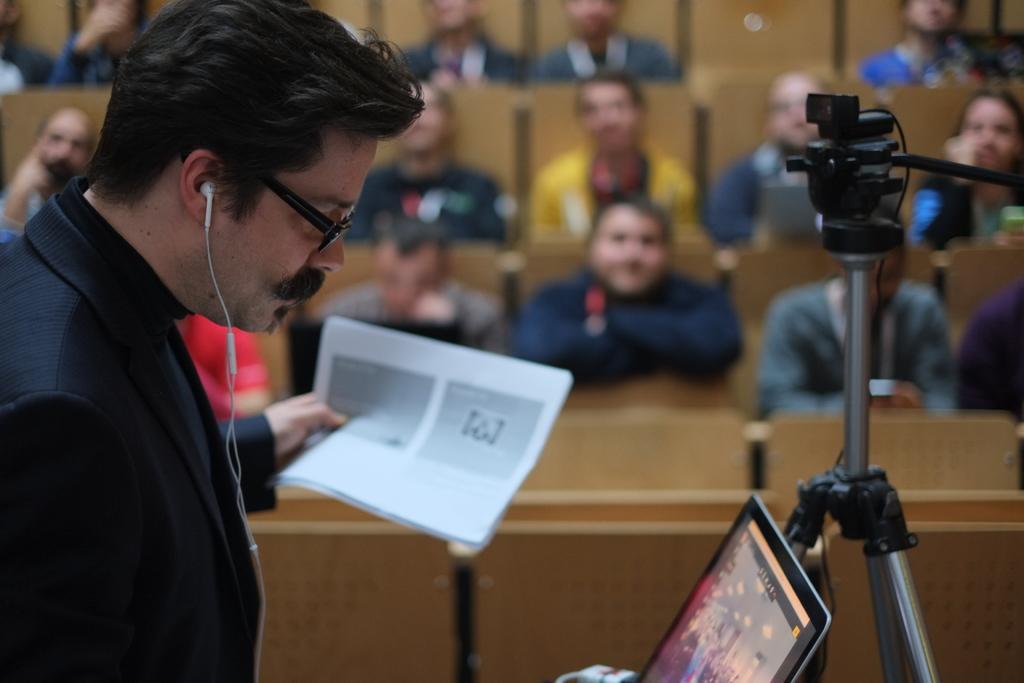Please provide a concise description of this image. In this image we can see a person wearing specs and headset is holding papers. In front of him there is a laptop. And there is a stand. In the back there are many people sitting on chairs. 